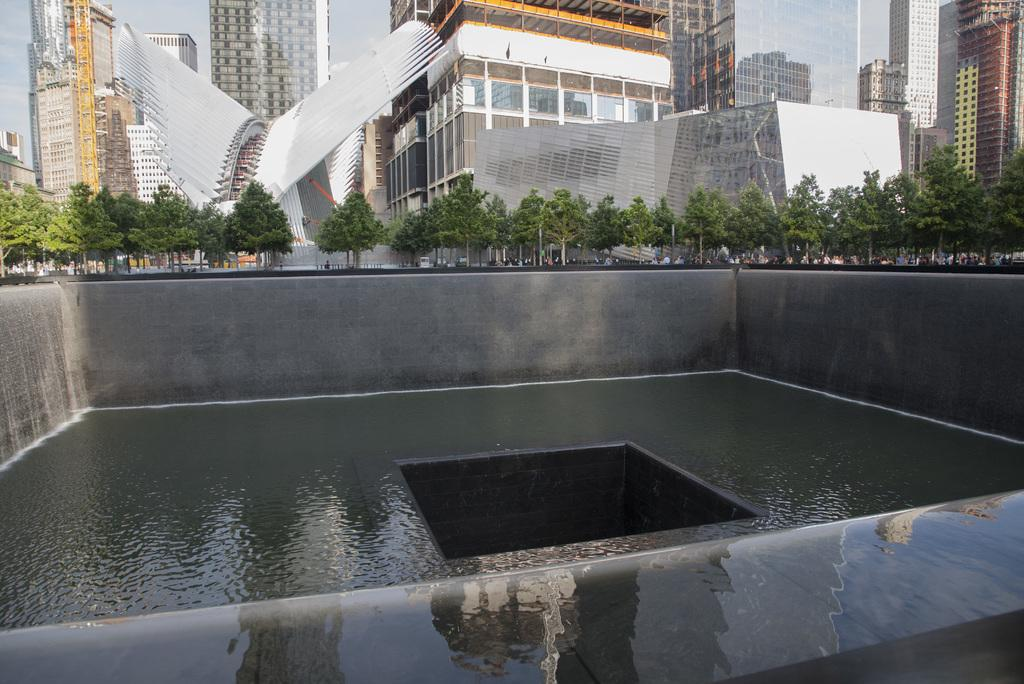What is one of the main elements in the image? There is water in the image. What is the large hole in the image like? The large hole in the image is black in color. What type of vegetation can be seen in the image? There are green trees in the image. Can you describe the people in the image? There are people in the image. What type of structures are present in the image? There are buildings in the image. What can be seen in the background of the image? The sky is visible in the background of the image. What type of passenger is being transported by the band in the image? There is no band or passenger present in the image. What type of stew is being served in the image? There is no stew present in the image. 